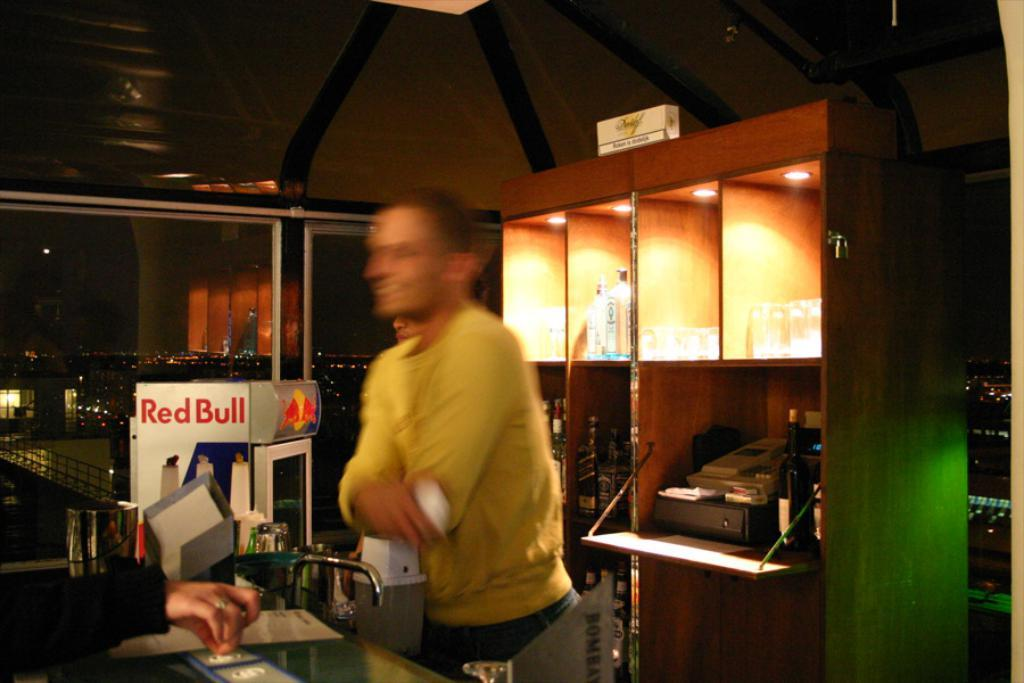<image>
Summarize the visual content of the image. Red bull is being advertised beside the man behind the bar. 